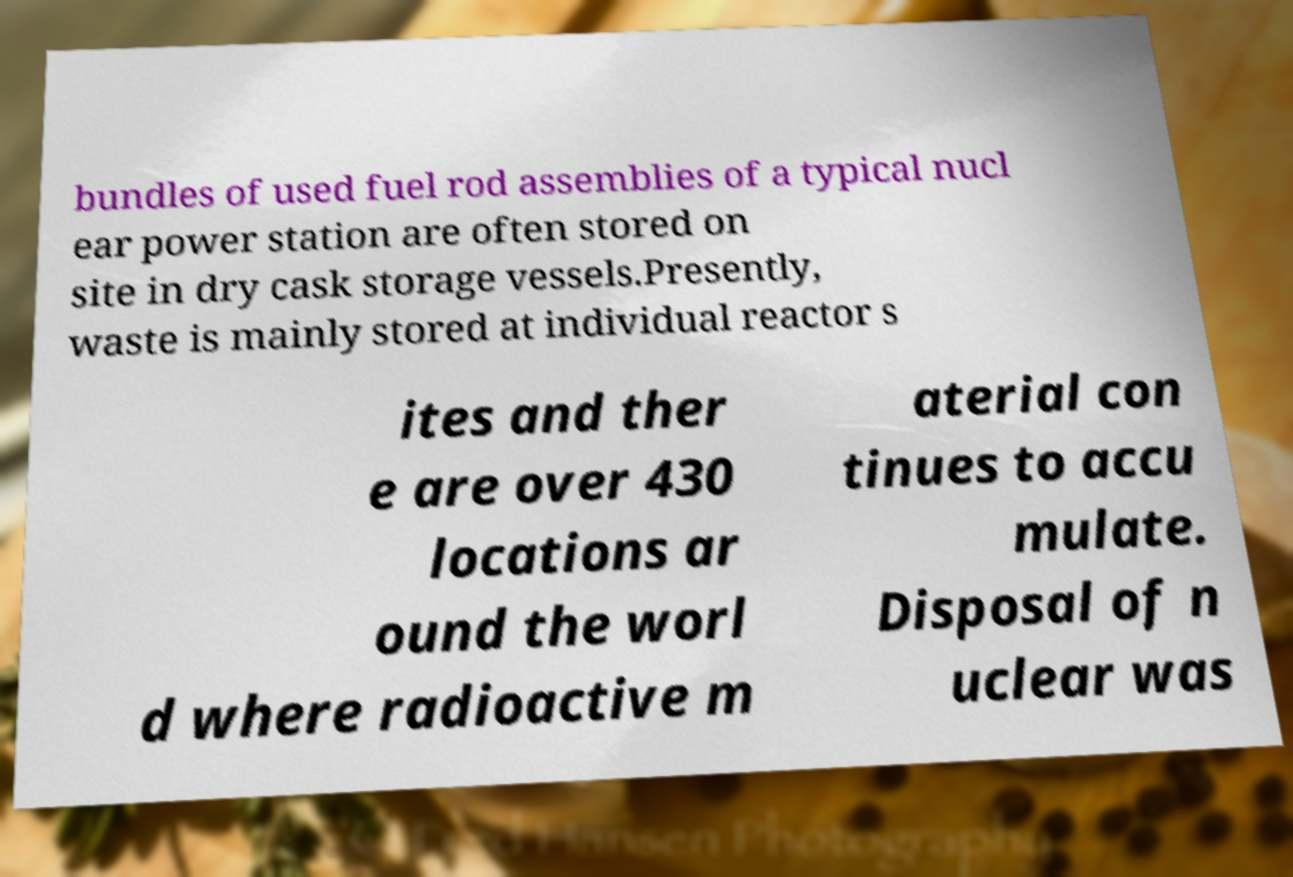Can you accurately transcribe the text from the provided image for me? bundles of used fuel rod assemblies of a typical nucl ear power station are often stored on site in dry cask storage vessels.Presently, waste is mainly stored at individual reactor s ites and ther e are over 430 locations ar ound the worl d where radioactive m aterial con tinues to accu mulate. Disposal of n uclear was 